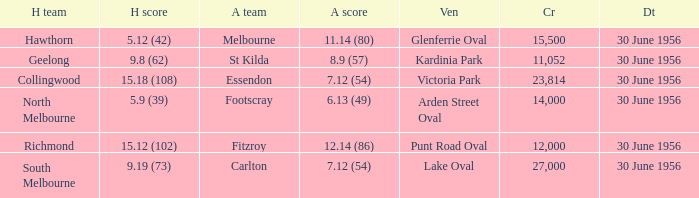What is the home team score when the away team is Melbourne? 5.12 (42). 